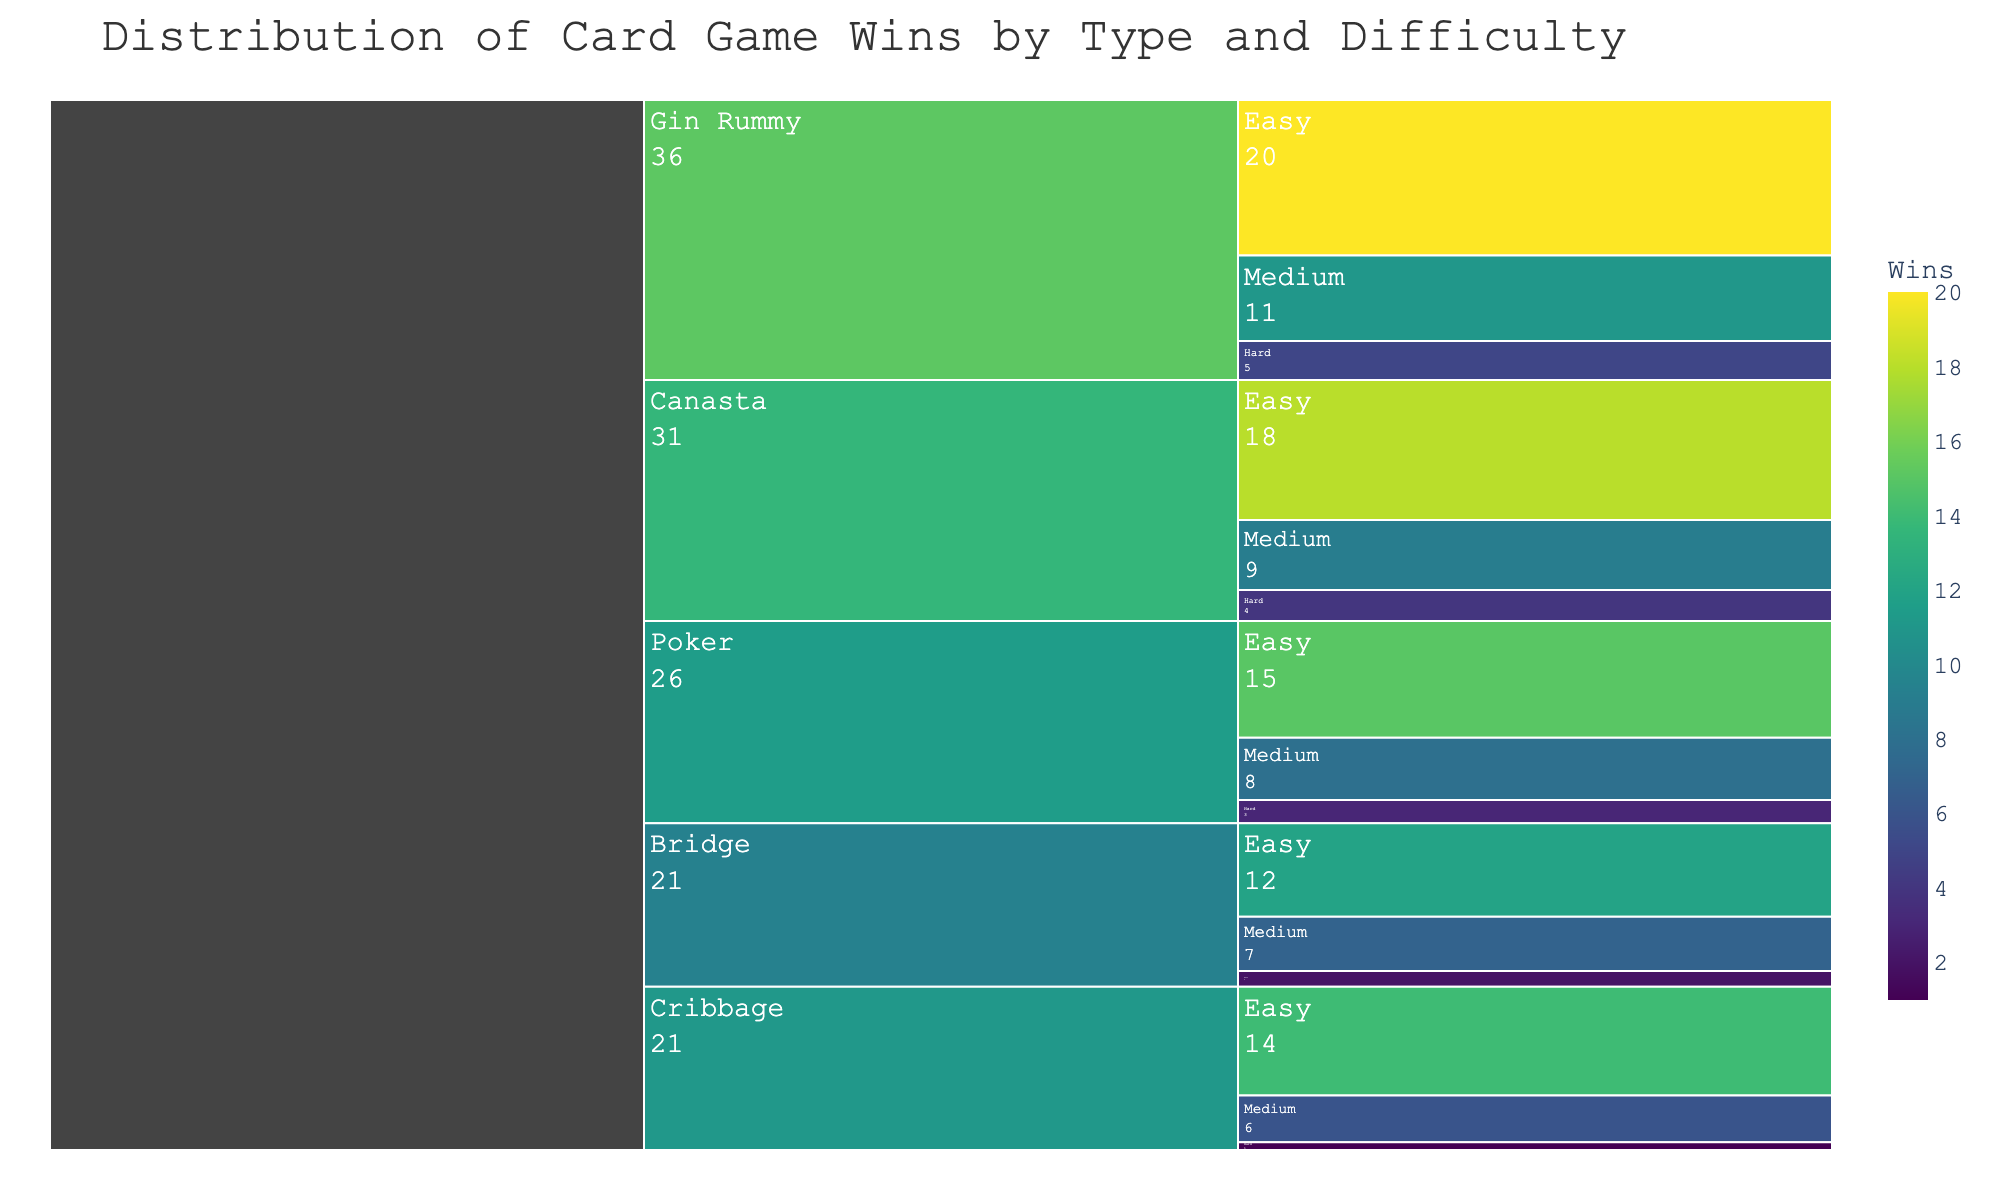Which game type has the highest number of wins in the 'Easy' difficulty? Locate the 'Easy' difficulty branch for each game type, then compare the win numbers. Gin Rummy has 20 wins, the highest among all game types in the 'Easy' difficulty.
Answer: Gin Rummy How many total wins are there for the 'Bridge' game type across all difficulty levels? Sum the wins for all difficulty levels under 'Bridge': Easy (12), Medium (7), and Hard (2). 12 + 7 + 2 = 21.
Answer: 21 Which difficulty level has the lowest number of wins for the 'Cribbage' game type? Locate all branches under 'Cribbage', then compare their win numbers. Hard has 1 win, the lowest.
Answer: Hard Compare the total wins for 'Poker' and 'Canasta'. Which has a higher number of wins? Sum the wins for all difficulty levels under 'Poker': Easy (15), Medium (8), and Hard (3), giving 15 + 8 + 3 = 26. Do the same for 'Canasta': Easy (18), Medium (9), and Hard (4), giving 18 + 9 + 4 = 31. Canasta has more wins.
Answer: Canasta What is the color range used to represent the number of wins? Observe the color legend for the plot and note the start and end colors in the gradient scale. The plot uses a Viridis color scale ranging from a dark color for the lowest wins to a bright yellow for the highest wins.
Answer: Dark to Bright Yellow What's the combined win total for games in the 'Medium' difficulty level across all game types? Sum the wins for 'Medium' difficulty across all game types: Poker (8), Bridge (7), Gin Rummy (11), Canasta (9), and Cribbage (6). 8 + 7 + 11 + 9 + 6 = 41.
Answer: 41 Which game type has a more even distribution of wins across all difficulty levels? Evaluate the difference in wins across difficulty levels for each game type. 'Canasta' shows relatively even distribution (Easy: 18, Medium: 9, Hard: 4), compared to others with larger gaps.
Answer: Canasta 